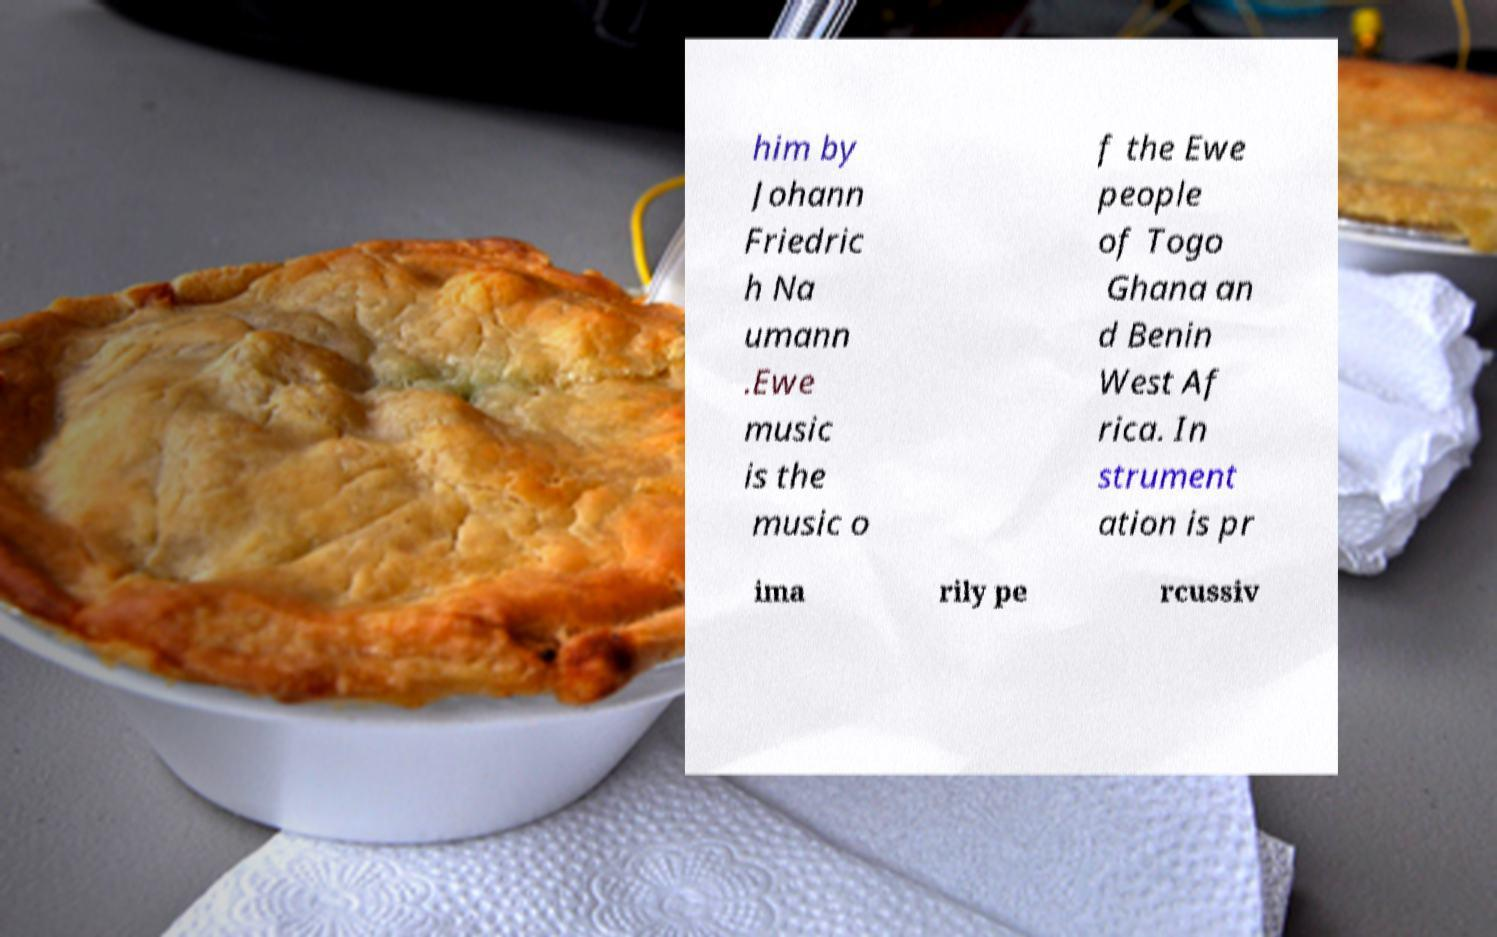Can you accurately transcribe the text from the provided image for me? him by Johann Friedric h Na umann .Ewe music is the music o f the Ewe people of Togo Ghana an d Benin West Af rica. In strument ation is pr ima rily pe rcussiv 